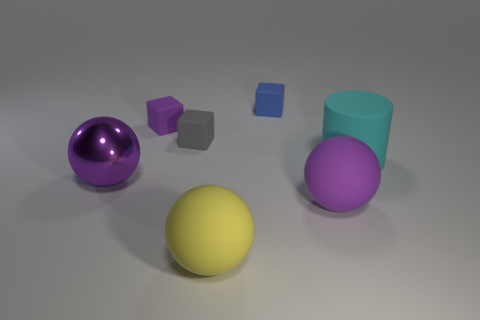Add 1 small purple blocks. How many objects exist? 8 Subtract all spheres. How many objects are left? 4 Add 2 green metal spheres. How many green metal spheres exist? 2 Subtract 0 blue spheres. How many objects are left? 7 Subtract all large cyan rubber cylinders. Subtract all large yellow things. How many objects are left? 5 Add 3 large yellow rubber balls. How many large yellow rubber balls are left? 4 